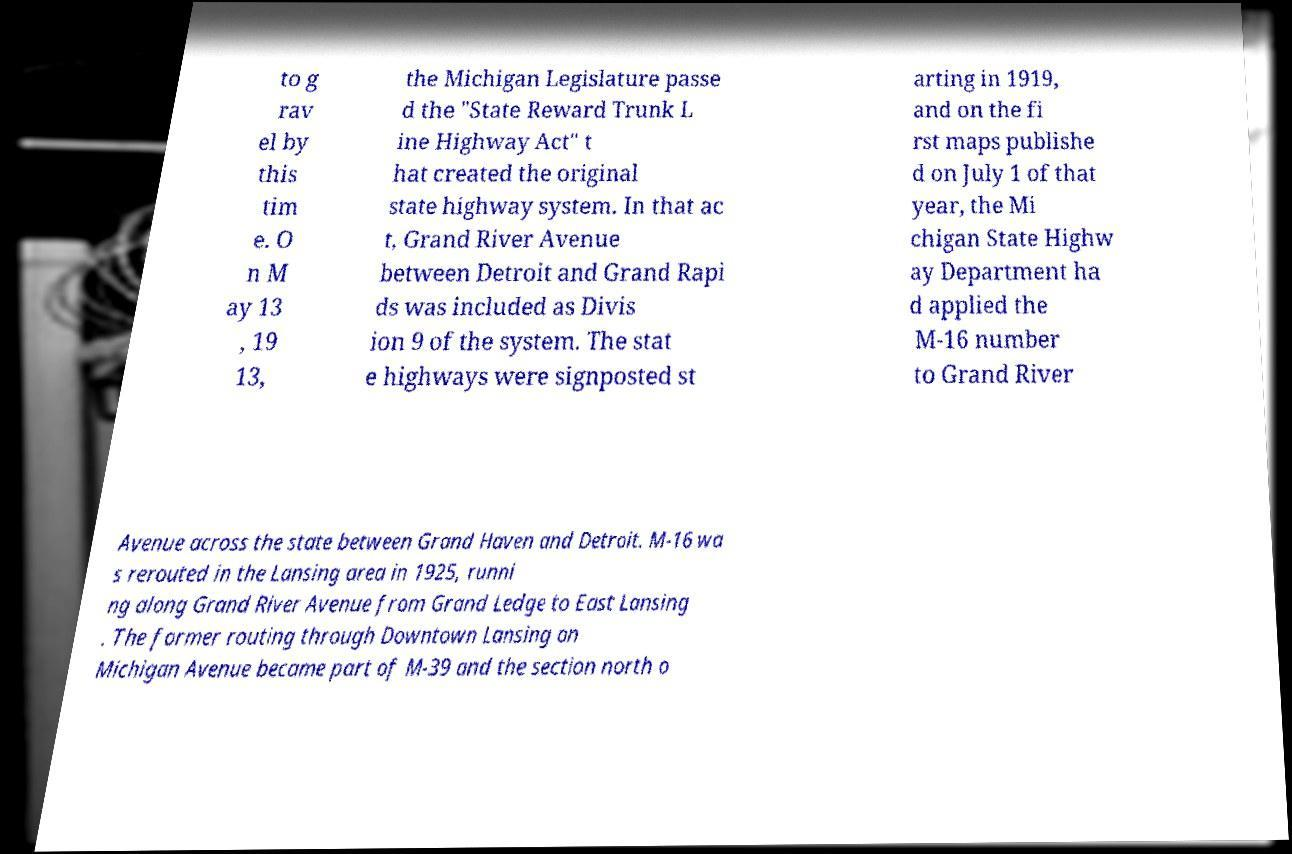Could you extract and type out the text from this image? to g rav el by this tim e. O n M ay 13 , 19 13, the Michigan Legislature passe d the "State Reward Trunk L ine Highway Act" t hat created the original state highway system. In that ac t, Grand River Avenue between Detroit and Grand Rapi ds was included as Divis ion 9 of the system. The stat e highways were signposted st arting in 1919, and on the fi rst maps publishe d on July 1 of that year, the Mi chigan State Highw ay Department ha d applied the M-16 number to Grand River Avenue across the state between Grand Haven and Detroit. M-16 wa s rerouted in the Lansing area in 1925, runni ng along Grand River Avenue from Grand Ledge to East Lansing . The former routing through Downtown Lansing on Michigan Avenue became part of M-39 and the section north o 